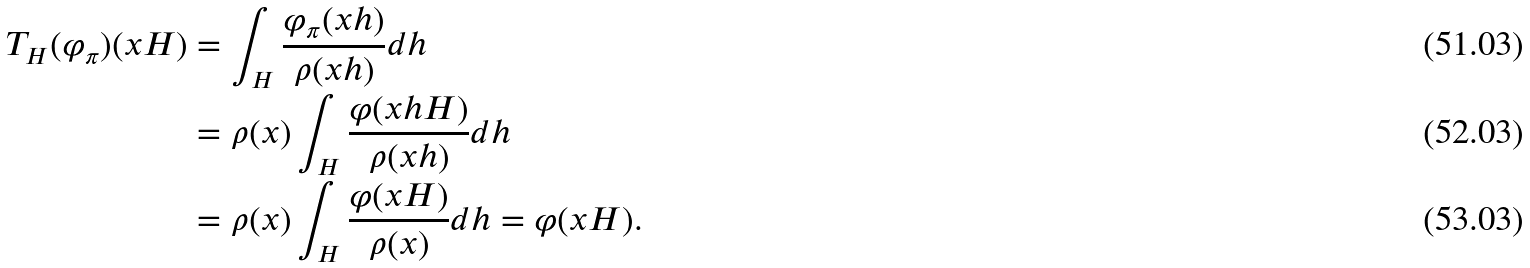<formula> <loc_0><loc_0><loc_500><loc_500>T _ { H } ( \varphi _ { \pi } ) ( x H ) & = \int _ { H } \frac { \varphi _ { \pi } ( x h ) } { \rho ( x h ) } d h \\ & = \rho ( x ) \int _ { H } \frac { \varphi ( x h H ) } { \rho ( x h ) } d h \\ & = \rho ( x ) \int _ { H } \frac { \varphi ( x H ) } { \rho ( x ) } d h = \varphi ( x H ) .</formula> 